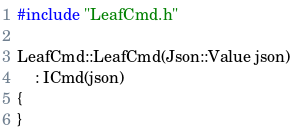Convert code to text. <code><loc_0><loc_0><loc_500><loc_500><_C++_>#include "LeafCmd.h"

LeafCmd::LeafCmd(Json::Value json)
    : ICmd(json)
{
}
</code> 